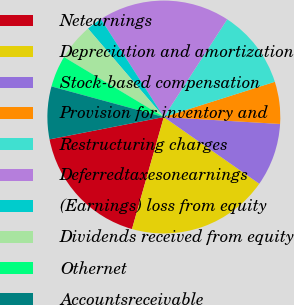Convert chart. <chart><loc_0><loc_0><loc_500><loc_500><pie_chart><fcel>Netearnings<fcel>Depreciation and amortization<fcel>Stock-based compensation<fcel>Provision for inventory and<fcel>Restructuring charges<fcel>Deferredtaxesonearnings<fcel>(Earnings) loss from equity<fcel>Dividends received from equity<fcel>Othernet<fcel>Accountsreceivable<nl><fcel>17.52%<fcel>19.7%<fcel>8.76%<fcel>5.84%<fcel>10.95%<fcel>18.25%<fcel>2.19%<fcel>5.11%<fcel>4.38%<fcel>7.3%<nl></chart> 